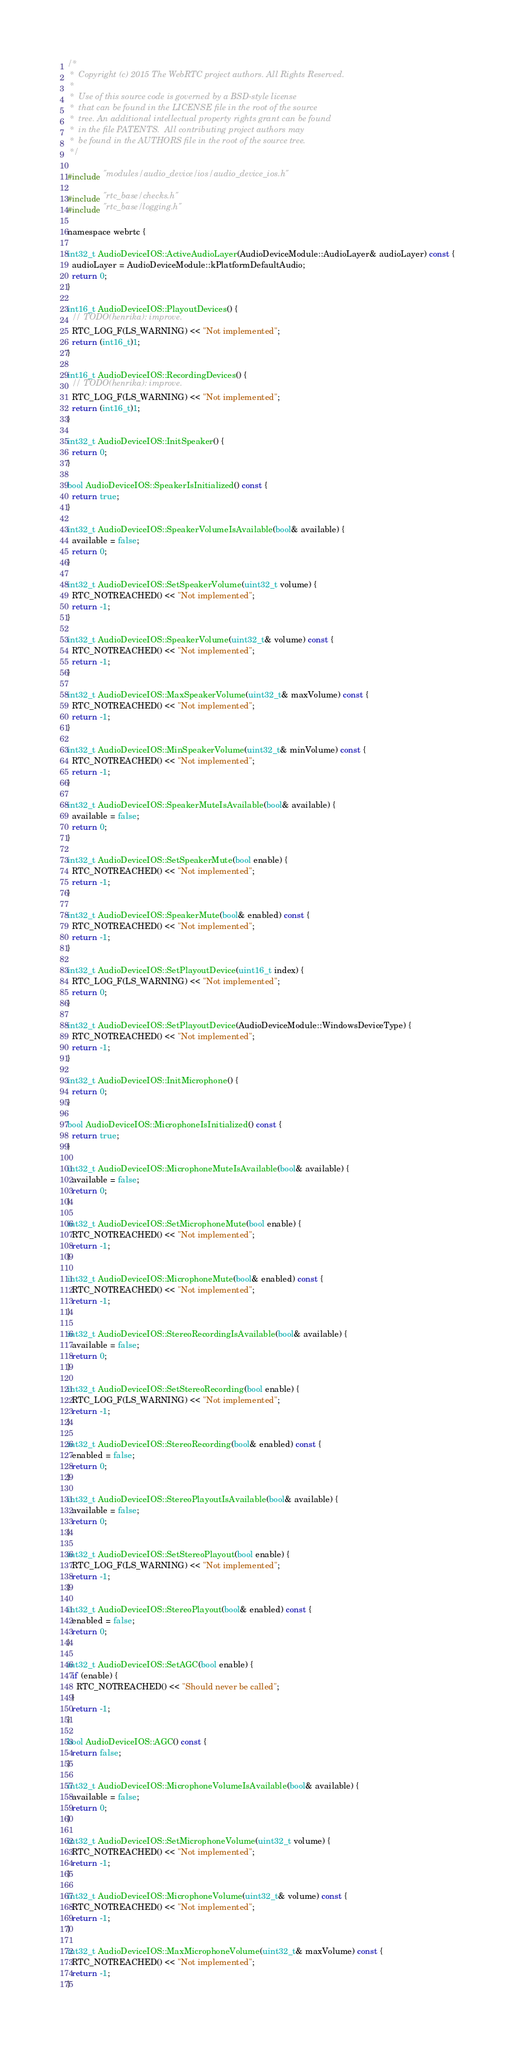<code> <loc_0><loc_0><loc_500><loc_500><_ObjectiveC_>/*
 *  Copyright (c) 2015 The WebRTC project authors. All Rights Reserved.
 *
 *  Use of this source code is governed by a BSD-style license
 *  that can be found in the LICENSE file in the root of the source
 *  tree. An additional intellectual property rights grant can be found
 *  in the file PATENTS.  All contributing project authors may
 *  be found in the AUTHORS file in the root of the source tree.
 */

#include "modules/audio_device/ios/audio_device_ios.h"

#include "rtc_base/checks.h"
#include "rtc_base/logging.h"

namespace webrtc {

int32_t AudioDeviceIOS::ActiveAudioLayer(AudioDeviceModule::AudioLayer& audioLayer) const {
  audioLayer = AudioDeviceModule::kPlatformDefaultAudio;
  return 0;
}

int16_t AudioDeviceIOS::PlayoutDevices() {
  // TODO(henrika): improve.
  RTC_LOG_F(LS_WARNING) << "Not implemented";
  return (int16_t)1;
}

int16_t AudioDeviceIOS::RecordingDevices() {
  // TODO(henrika): improve.
  RTC_LOG_F(LS_WARNING) << "Not implemented";
  return (int16_t)1;
}

int32_t AudioDeviceIOS::InitSpeaker() {
  return 0;
}

bool AudioDeviceIOS::SpeakerIsInitialized() const {
  return true;
}

int32_t AudioDeviceIOS::SpeakerVolumeIsAvailable(bool& available) {
  available = false;
  return 0;
}

int32_t AudioDeviceIOS::SetSpeakerVolume(uint32_t volume) {
  RTC_NOTREACHED() << "Not implemented";
  return -1;
}

int32_t AudioDeviceIOS::SpeakerVolume(uint32_t& volume) const {
  RTC_NOTREACHED() << "Not implemented";
  return -1;
}

int32_t AudioDeviceIOS::MaxSpeakerVolume(uint32_t& maxVolume) const {
  RTC_NOTREACHED() << "Not implemented";
  return -1;
}

int32_t AudioDeviceIOS::MinSpeakerVolume(uint32_t& minVolume) const {
  RTC_NOTREACHED() << "Not implemented";
  return -1;
}

int32_t AudioDeviceIOS::SpeakerMuteIsAvailable(bool& available) {
  available = false;
  return 0;
}

int32_t AudioDeviceIOS::SetSpeakerMute(bool enable) {
  RTC_NOTREACHED() << "Not implemented";
  return -1;
}

int32_t AudioDeviceIOS::SpeakerMute(bool& enabled) const {
  RTC_NOTREACHED() << "Not implemented";
  return -1;
}

int32_t AudioDeviceIOS::SetPlayoutDevice(uint16_t index) {
  RTC_LOG_F(LS_WARNING) << "Not implemented";
  return 0;
}

int32_t AudioDeviceIOS::SetPlayoutDevice(AudioDeviceModule::WindowsDeviceType) {
  RTC_NOTREACHED() << "Not implemented";
  return -1;
}

int32_t AudioDeviceIOS::InitMicrophone() {
  return 0;
}

bool AudioDeviceIOS::MicrophoneIsInitialized() const {
  return true;
}

int32_t AudioDeviceIOS::MicrophoneMuteIsAvailable(bool& available) {
  available = false;
  return 0;
}

int32_t AudioDeviceIOS::SetMicrophoneMute(bool enable) {
  RTC_NOTREACHED() << "Not implemented";
  return -1;
}

int32_t AudioDeviceIOS::MicrophoneMute(bool& enabled) const {
  RTC_NOTREACHED() << "Not implemented";
  return -1;
}

int32_t AudioDeviceIOS::StereoRecordingIsAvailable(bool& available) {
  available = false;
  return 0;
}

int32_t AudioDeviceIOS::SetStereoRecording(bool enable) {
  RTC_LOG_F(LS_WARNING) << "Not implemented";
  return -1;
}

int32_t AudioDeviceIOS::StereoRecording(bool& enabled) const {
  enabled = false;
  return 0;
}

int32_t AudioDeviceIOS::StereoPlayoutIsAvailable(bool& available) {
  available = false;
  return 0;
}

int32_t AudioDeviceIOS::SetStereoPlayout(bool enable) {
  RTC_LOG_F(LS_WARNING) << "Not implemented";
  return -1;
}

int32_t AudioDeviceIOS::StereoPlayout(bool& enabled) const {
  enabled = false;
  return 0;
}

int32_t AudioDeviceIOS::SetAGC(bool enable) {
  if (enable) {
    RTC_NOTREACHED() << "Should never be called";
  }
  return -1;
}

bool AudioDeviceIOS::AGC() const {
  return false;
}

int32_t AudioDeviceIOS::MicrophoneVolumeIsAvailable(bool& available) {
  available = false;
  return 0;
}

int32_t AudioDeviceIOS::SetMicrophoneVolume(uint32_t volume) {
  RTC_NOTREACHED() << "Not implemented";
  return -1;
}

int32_t AudioDeviceIOS::MicrophoneVolume(uint32_t& volume) const {
  RTC_NOTREACHED() << "Not implemented";
  return -1;
}

int32_t AudioDeviceIOS::MaxMicrophoneVolume(uint32_t& maxVolume) const {
  RTC_NOTREACHED() << "Not implemented";
  return -1;
}
</code> 